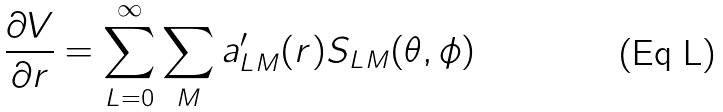<formula> <loc_0><loc_0><loc_500><loc_500>\frac { \partial V } { \partial r } = \sum _ { L = 0 } ^ { \infty } \sum _ { M } a ^ { \prime } _ { L M } ( r ) S _ { L M } ( \theta , \phi )</formula> 